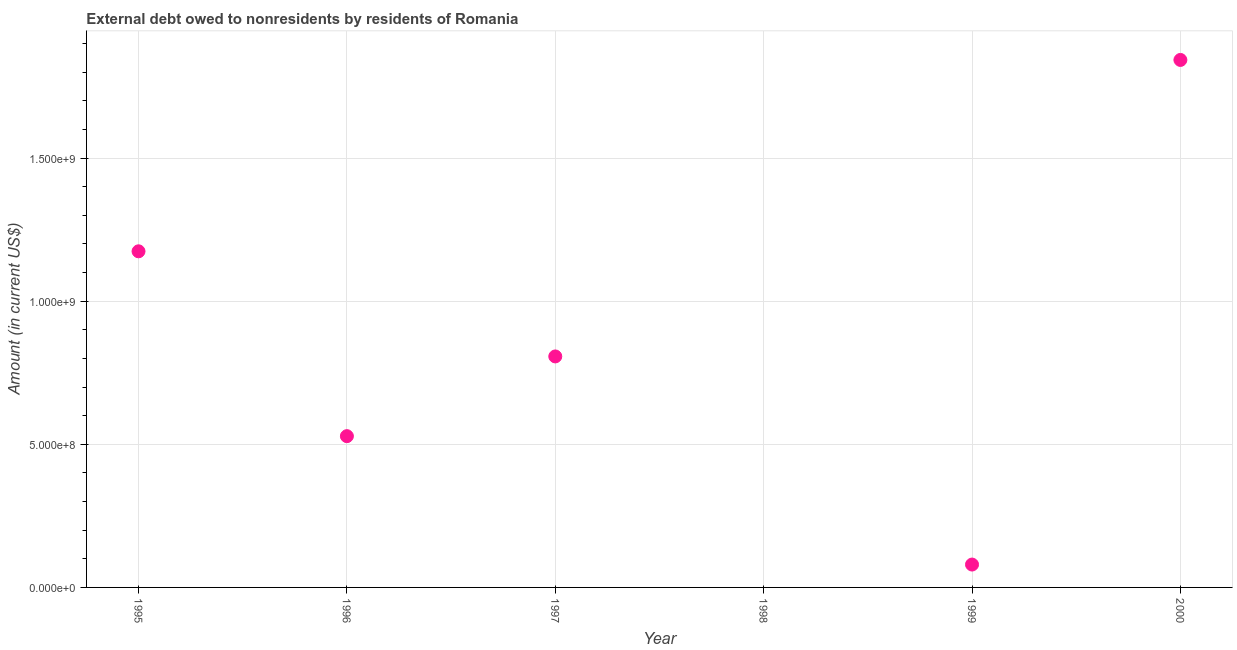What is the debt in 2000?
Make the answer very short. 1.84e+09. Across all years, what is the maximum debt?
Keep it short and to the point. 1.84e+09. Across all years, what is the minimum debt?
Offer a terse response. 0. What is the sum of the debt?
Your answer should be very brief. 4.43e+09. What is the difference between the debt in 1996 and 2000?
Your response must be concise. -1.31e+09. What is the average debt per year?
Ensure brevity in your answer.  7.39e+08. What is the median debt?
Your response must be concise. 6.68e+08. In how many years, is the debt greater than 1000000000 US$?
Provide a succinct answer. 2. What is the ratio of the debt in 1999 to that in 2000?
Provide a short and direct response. 0.04. Is the difference between the debt in 1997 and 1999 greater than the difference between any two years?
Make the answer very short. No. What is the difference between the highest and the second highest debt?
Offer a very short reply. 6.68e+08. What is the difference between the highest and the lowest debt?
Your answer should be very brief. 1.84e+09. In how many years, is the debt greater than the average debt taken over all years?
Your response must be concise. 3. Does the debt monotonically increase over the years?
Your answer should be very brief. No. How many dotlines are there?
Provide a short and direct response. 1. What is the difference between two consecutive major ticks on the Y-axis?
Your response must be concise. 5.00e+08. Does the graph contain any zero values?
Provide a short and direct response. Yes. What is the title of the graph?
Offer a very short reply. External debt owed to nonresidents by residents of Romania. What is the Amount (in current US$) in 1995?
Your answer should be compact. 1.17e+09. What is the Amount (in current US$) in 1996?
Provide a short and direct response. 5.28e+08. What is the Amount (in current US$) in 1997?
Offer a terse response. 8.07e+08. What is the Amount (in current US$) in 1999?
Offer a terse response. 7.99e+07. What is the Amount (in current US$) in 2000?
Your answer should be very brief. 1.84e+09. What is the difference between the Amount (in current US$) in 1995 and 1996?
Ensure brevity in your answer.  6.46e+08. What is the difference between the Amount (in current US$) in 1995 and 1997?
Keep it short and to the point. 3.67e+08. What is the difference between the Amount (in current US$) in 1995 and 1999?
Provide a succinct answer. 1.09e+09. What is the difference between the Amount (in current US$) in 1995 and 2000?
Offer a very short reply. -6.68e+08. What is the difference between the Amount (in current US$) in 1996 and 1997?
Offer a terse response. -2.78e+08. What is the difference between the Amount (in current US$) in 1996 and 1999?
Provide a succinct answer. 4.49e+08. What is the difference between the Amount (in current US$) in 1996 and 2000?
Provide a succinct answer. -1.31e+09. What is the difference between the Amount (in current US$) in 1997 and 1999?
Give a very brief answer. 7.27e+08. What is the difference between the Amount (in current US$) in 1997 and 2000?
Keep it short and to the point. -1.04e+09. What is the difference between the Amount (in current US$) in 1999 and 2000?
Offer a terse response. -1.76e+09. What is the ratio of the Amount (in current US$) in 1995 to that in 1996?
Give a very brief answer. 2.22. What is the ratio of the Amount (in current US$) in 1995 to that in 1997?
Provide a succinct answer. 1.46. What is the ratio of the Amount (in current US$) in 1995 to that in 1999?
Offer a very short reply. 14.69. What is the ratio of the Amount (in current US$) in 1995 to that in 2000?
Your answer should be very brief. 0.64. What is the ratio of the Amount (in current US$) in 1996 to that in 1997?
Provide a short and direct response. 0.66. What is the ratio of the Amount (in current US$) in 1996 to that in 1999?
Offer a terse response. 6.61. What is the ratio of the Amount (in current US$) in 1996 to that in 2000?
Your response must be concise. 0.29. What is the ratio of the Amount (in current US$) in 1997 to that in 1999?
Provide a succinct answer. 10.1. What is the ratio of the Amount (in current US$) in 1997 to that in 2000?
Keep it short and to the point. 0.44. What is the ratio of the Amount (in current US$) in 1999 to that in 2000?
Provide a short and direct response. 0.04. 